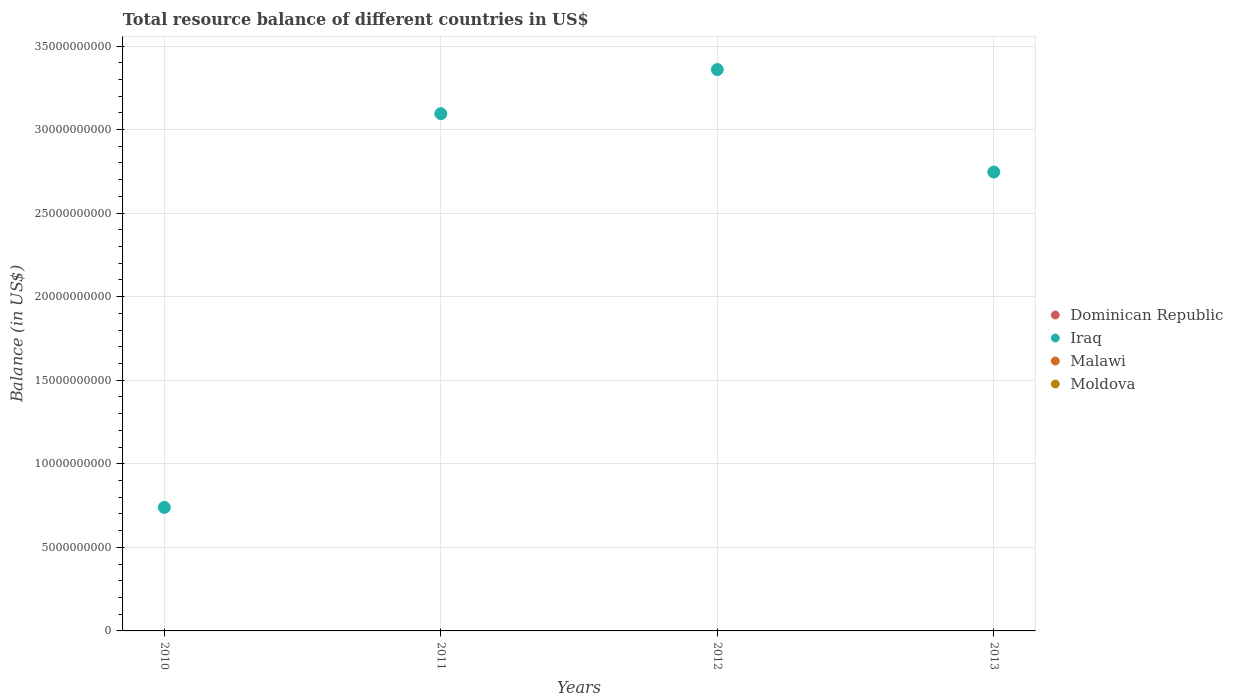Is the number of dotlines equal to the number of legend labels?
Ensure brevity in your answer.  No. Across all years, what is the minimum total resource balance in Iraq?
Provide a short and direct response. 7.39e+09. What is the difference between the total resource balance in Iraq in 2011 and that in 2013?
Your answer should be very brief. 3.49e+09. What is the difference between the total resource balance in Malawi in 2011 and the total resource balance in Iraq in 2012?
Provide a short and direct response. -3.36e+1. What is the average total resource balance in Iraq per year?
Offer a very short reply. 2.48e+1. What is the ratio of the total resource balance in Iraq in 2010 to that in 2013?
Offer a very short reply. 0.27. Is the total resource balance in Iraq in 2010 less than that in 2011?
Make the answer very short. Yes. What is the difference between the highest and the second highest total resource balance in Iraq?
Provide a short and direct response. 2.64e+09. What is the difference between the highest and the lowest total resource balance in Iraq?
Offer a very short reply. 2.62e+1. Is it the case that in every year, the sum of the total resource balance in Malawi and total resource balance in Dominican Republic  is greater than the sum of total resource balance in Iraq and total resource balance in Moldova?
Your answer should be compact. No. Is the total resource balance in Dominican Republic strictly less than the total resource balance in Iraq over the years?
Offer a very short reply. Yes. Are the values on the major ticks of Y-axis written in scientific E-notation?
Offer a very short reply. No. Does the graph contain grids?
Offer a very short reply. Yes. What is the title of the graph?
Provide a succinct answer. Total resource balance of different countries in US$. Does "Bosnia and Herzegovina" appear as one of the legend labels in the graph?
Make the answer very short. No. What is the label or title of the Y-axis?
Ensure brevity in your answer.  Balance (in US$). What is the Balance (in US$) of Iraq in 2010?
Offer a terse response. 7.39e+09. What is the Balance (in US$) in Dominican Republic in 2011?
Provide a succinct answer. 0. What is the Balance (in US$) of Iraq in 2011?
Offer a terse response. 3.10e+1. What is the Balance (in US$) in Malawi in 2011?
Ensure brevity in your answer.  0. What is the Balance (in US$) of Iraq in 2012?
Your answer should be very brief. 3.36e+1. What is the Balance (in US$) of Malawi in 2012?
Provide a succinct answer. 0. What is the Balance (in US$) of Moldova in 2012?
Make the answer very short. 0. What is the Balance (in US$) of Dominican Republic in 2013?
Provide a short and direct response. 0. What is the Balance (in US$) in Iraq in 2013?
Give a very brief answer. 2.75e+1. What is the Balance (in US$) of Malawi in 2013?
Offer a terse response. 0. What is the Balance (in US$) in Moldova in 2013?
Ensure brevity in your answer.  0. Across all years, what is the maximum Balance (in US$) of Iraq?
Your response must be concise. 3.36e+1. Across all years, what is the minimum Balance (in US$) in Iraq?
Provide a succinct answer. 7.39e+09. What is the total Balance (in US$) in Iraq in the graph?
Your answer should be very brief. 9.94e+1. What is the total Balance (in US$) of Malawi in the graph?
Provide a succinct answer. 0. What is the total Balance (in US$) of Moldova in the graph?
Ensure brevity in your answer.  0. What is the difference between the Balance (in US$) of Iraq in 2010 and that in 2011?
Provide a succinct answer. -2.36e+1. What is the difference between the Balance (in US$) in Iraq in 2010 and that in 2012?
Offer a terse response. -2.62e+1. What is the difference between the Balance (in US$) in Iraq in 2010 and that in 2013?
Give a very brief answer. -2.01e+1. What is the difference between the Balance (in US$) in Iraq in 2011 and that in 2012?
Keep it short and to the point. -2.64e+09. What is the difference between the Balance (in US$) in Iraq in 2011 and that in 2013?
Keep it short and to the point. 3.49e+09. What is the difference between the Balance (in US$) of Iraq in 2012 and that in 2013?
Keep it short and to the point. 6.13e+09. What is the average Balance (in US$) of Iraq per year?
Your answer should be very brief. 2.48e+1. What is the average Balance (in US$) in Malawi per year?
Offer a very short reply. 0. What is the ratio of the Balance (in US$) in Iraq in 2010 to that in 2011?
Keep it short and to the point. 0.24. What is the ratio of the Balance (in US$) of Iraq in 2010 to that in 2012?
Offer a terse response. 0.22. What is the ratio of the Balance (in US$) of Iraq in 2010 to that in 2013?
Your answer should be compact. 0.27. What is the ratio of the Balance (in US$) in Iraq in 2011 to that in 2012?
Offer a very short reply. 0.92. What is the ratio of the Balance (in US$) of Iraq in 2011 to that in 2013?
Ensure brevity in your answer.  1.13. What is the ratio of the Balance (in US$) in Iraq in 2012 to that in 2013?
Make the answer very short. 1.22. What is the difference between the highest and the second highest Balance (in US$) of Iraq?
Offer a very short reply. 2.64e+09. What is the difference between the highest and the lowest Balance (in US$) in Iraq?
Offer a terse response. 2.62e+1. 